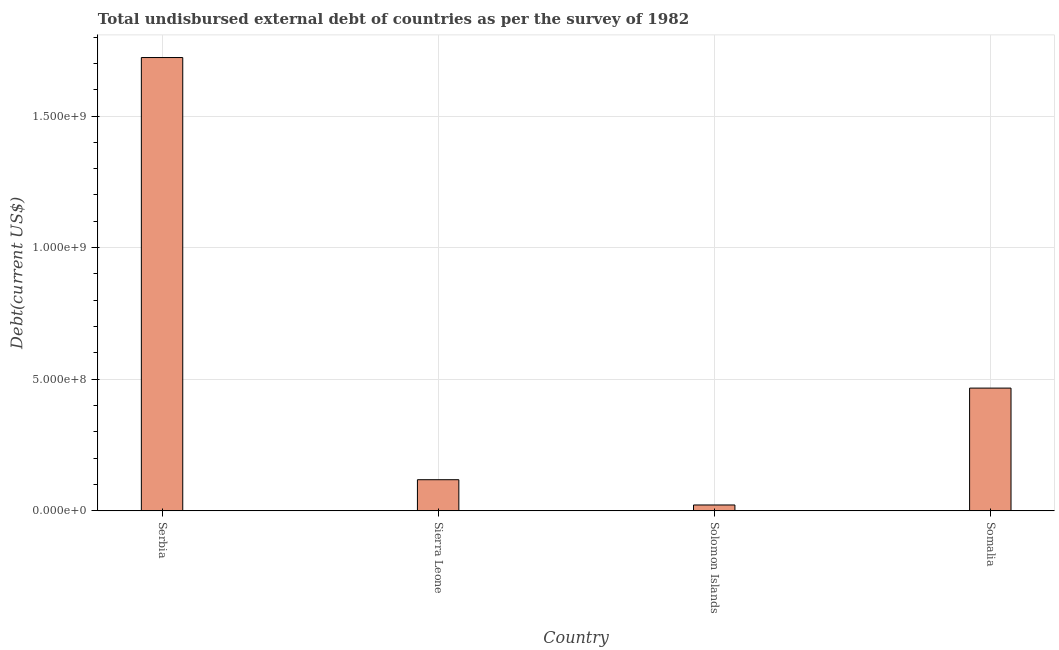Does the graph contain grids?
Keep it short and to the point. Yes. What is the title of the graph?
Offer a very short reply. Total undisbursed external debt of countries as per the survey of 1982. What is the label or title of the X-axis?
Ensure brevity in your answer.  Country. What is the label or title of the Y-axis?
Your response must be concise. Debt(current US$). What is the total debt in Serbia?
Your response must be concise. 1.72e+09. Across all countries, what is the maximum total debt?
Your answer should be compact. 1.72e+09. Across all countries, what is the minimum total debt?
Your answer should be compact. 2.22e+07. In which country was the total debt maximum?
Your answer should be very brief. Serbia. In which country was the total debt minimum?
Offer a terse response. Solomon Islands. What is the sum of the total debt?
Make the answer very short. 2.33e+09. What is the difference between the total debt in Serbia and Sierra Leone?
Ensure brevity in your answer.  1.60e+09. What is the average total debt per country?
Ensure brevity in your answer.  5.82e+08. What is the median total debt?
Your answer should be very brief. 2.92e+08. In how many countries, is the total debt greater than 1400000000 US$?
Provide a succinct answer. 1. What is the ratio of the total debt in Sierra Leone to that in Solomon Islands?
Your response must be concise. 5.32. What is the difference between the highest and the second highest total debt?
Provide a succinct answer. 1.26e+09. Is the sum of the total debt in Serbia and Somalia greater than the maximum total debt across all countries?
Provide a succinct answer. Yes. What is the difference between the highest and the lowest total debt?
Provide a short and direct response. 1.70e+09. In how many countries, is the total debt greater than the average total debt taken over all countries?
Offer a very short reply. 1. What is the difference between two consecutive major ticks on the Y-axis?
Offer a terse response. 5.00e+08. What is the Debt(current US$) of Serbia?
Ensure brevity in your answer.  1.72e+09. What is the Debt(current US$) of Sierra Leone?
Provide a succinct answer. 1.18e+08. What is the Debt(current US$) of Solomon Islands?
Provide a short and direct response. 2.22e+07. What is the Debt(current US$) of Somalia?
Offer a terse response. 4.66e+08. What is the difference between the Debt(current US$) in Serbia and Sierra Leone?
Provide a succinct answer. 1.60e+09. What is the difference between the Debt(current US$) in Serbia and Solomon Islands?
Make the answer very short. 1.70e+09. What is the difference between the Debt(current US$) in Serbia and Somalia?
Your answer should be very brief. 1.26e+09. What is the difference between the Debt(current US$) in Sierra Leone and Solomon Islands?
Your answer should be compact. 9.60e+07. What is the difference between the Debt(current US$) in Sierra Leone and Somalia?
Your answer should be very brief. -3.48e+08. What is the difference between the Debt(current US$) in Solomon Islands and Somalia?
Provide a succinct answer. -4.44e+08. What is the ratio of the Debt(current US$) in Serbia to that in Sierra Leone?
Make the answer very short. 14.57. What is the ratio of the Debt(current US$) in Serbia to that in Solomon Islands?
Provide a short and direct response. 77.49. What is the ratio of the Debt(current US$) in Serbia to that in Somalia?
Your answer should be very brief. 3.69. What is the ratio of the Debt(current US$) in Sierra Leone to that in Solomon Islands?
Provide a short and direct response. 5.32. What is the ratio of the Debt(current US$) in Sierra Leone to that in Somalia?
Your answer should be compact. 0.25. What is the ratio of the Debt(current US$) in Solomon Islands to that in Somalia?
Your answer should be compact. 0.05. 